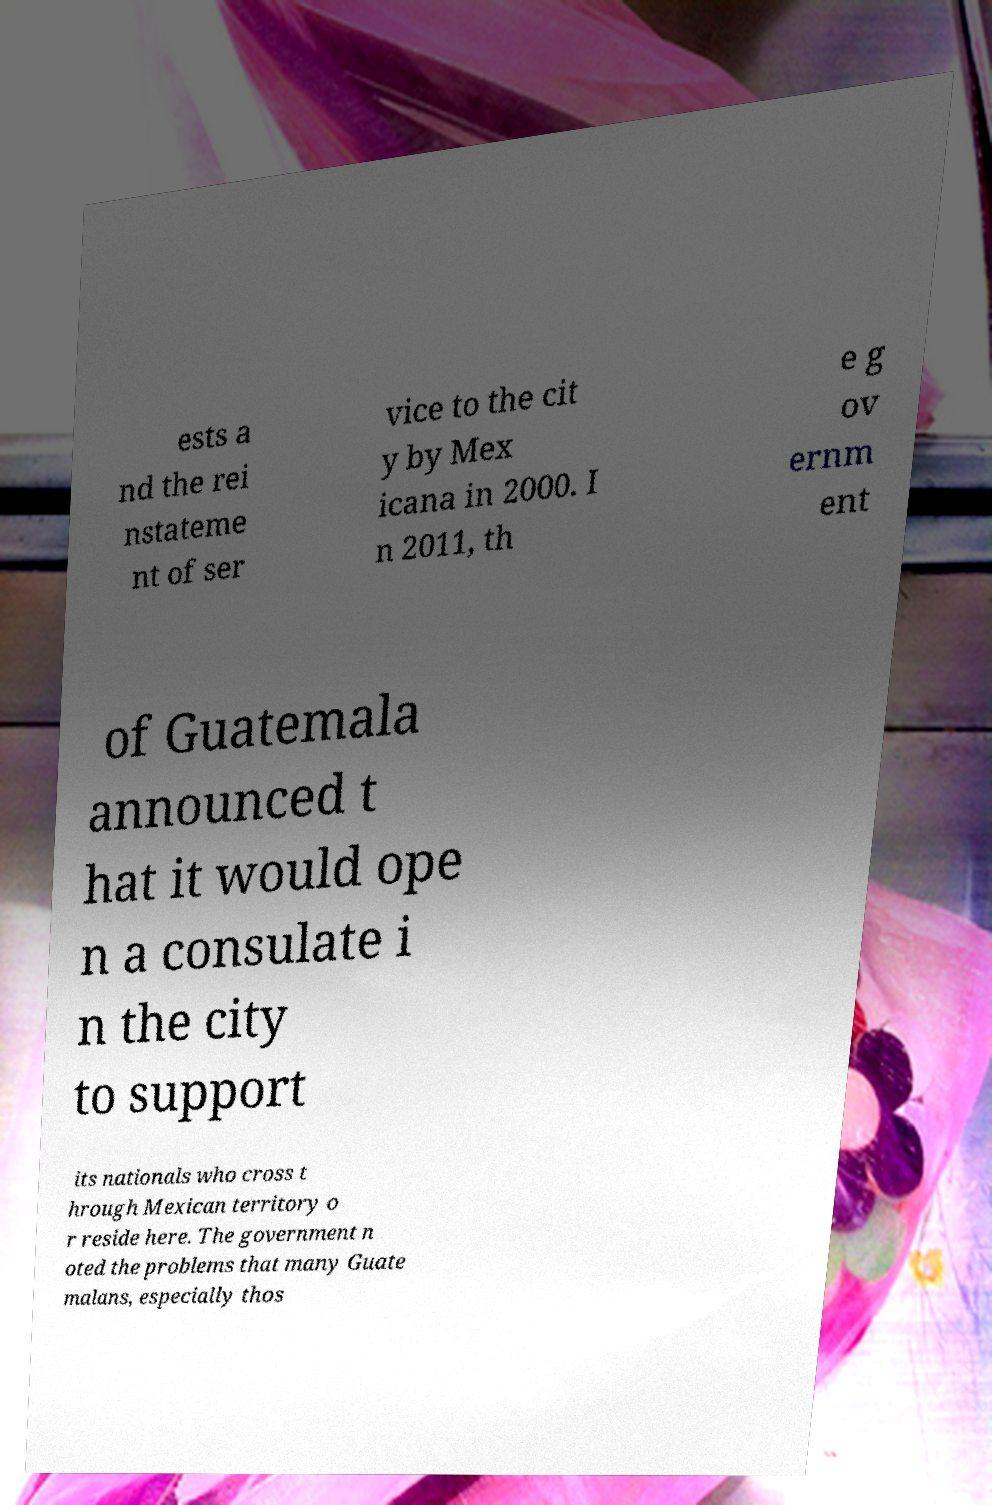What messages or text are displayed in this image? I need them in a readable, typed format. ests a nd the rei nstateme nt of ser vice to the cit y by Mex icana in 2000. I n 2011, th e g ov ernm ent of Guatemala announced t hat it would ope n a consulate i n the city to support its nationals who cross t hrough Mexican territory o r reside here. The government n oted the problems that many Guate malans, especially thos 